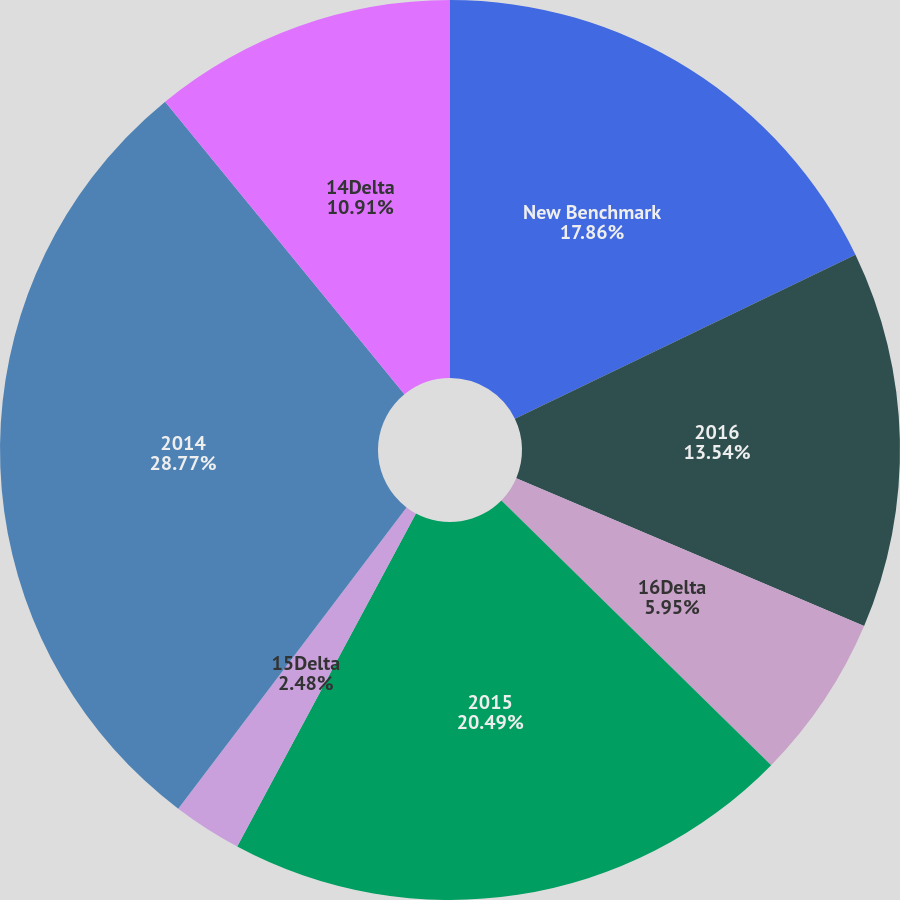Convert chart to OTSL. <chart><loc_0><loc_0><loc_500><loc_500><pie_chart><fcel>New Benchmark<fcel>2016<fcel>16Delta<fcel>2015<fcel>15Delta<fcel>2014<fcel>14Delta<nl><fcel>17.86%<fcel>13.54%<fcel>5.95%<fcel>20.49%<fcel>2.48%<fcel>28.77%<fcel>10.91%<nl></chart> 